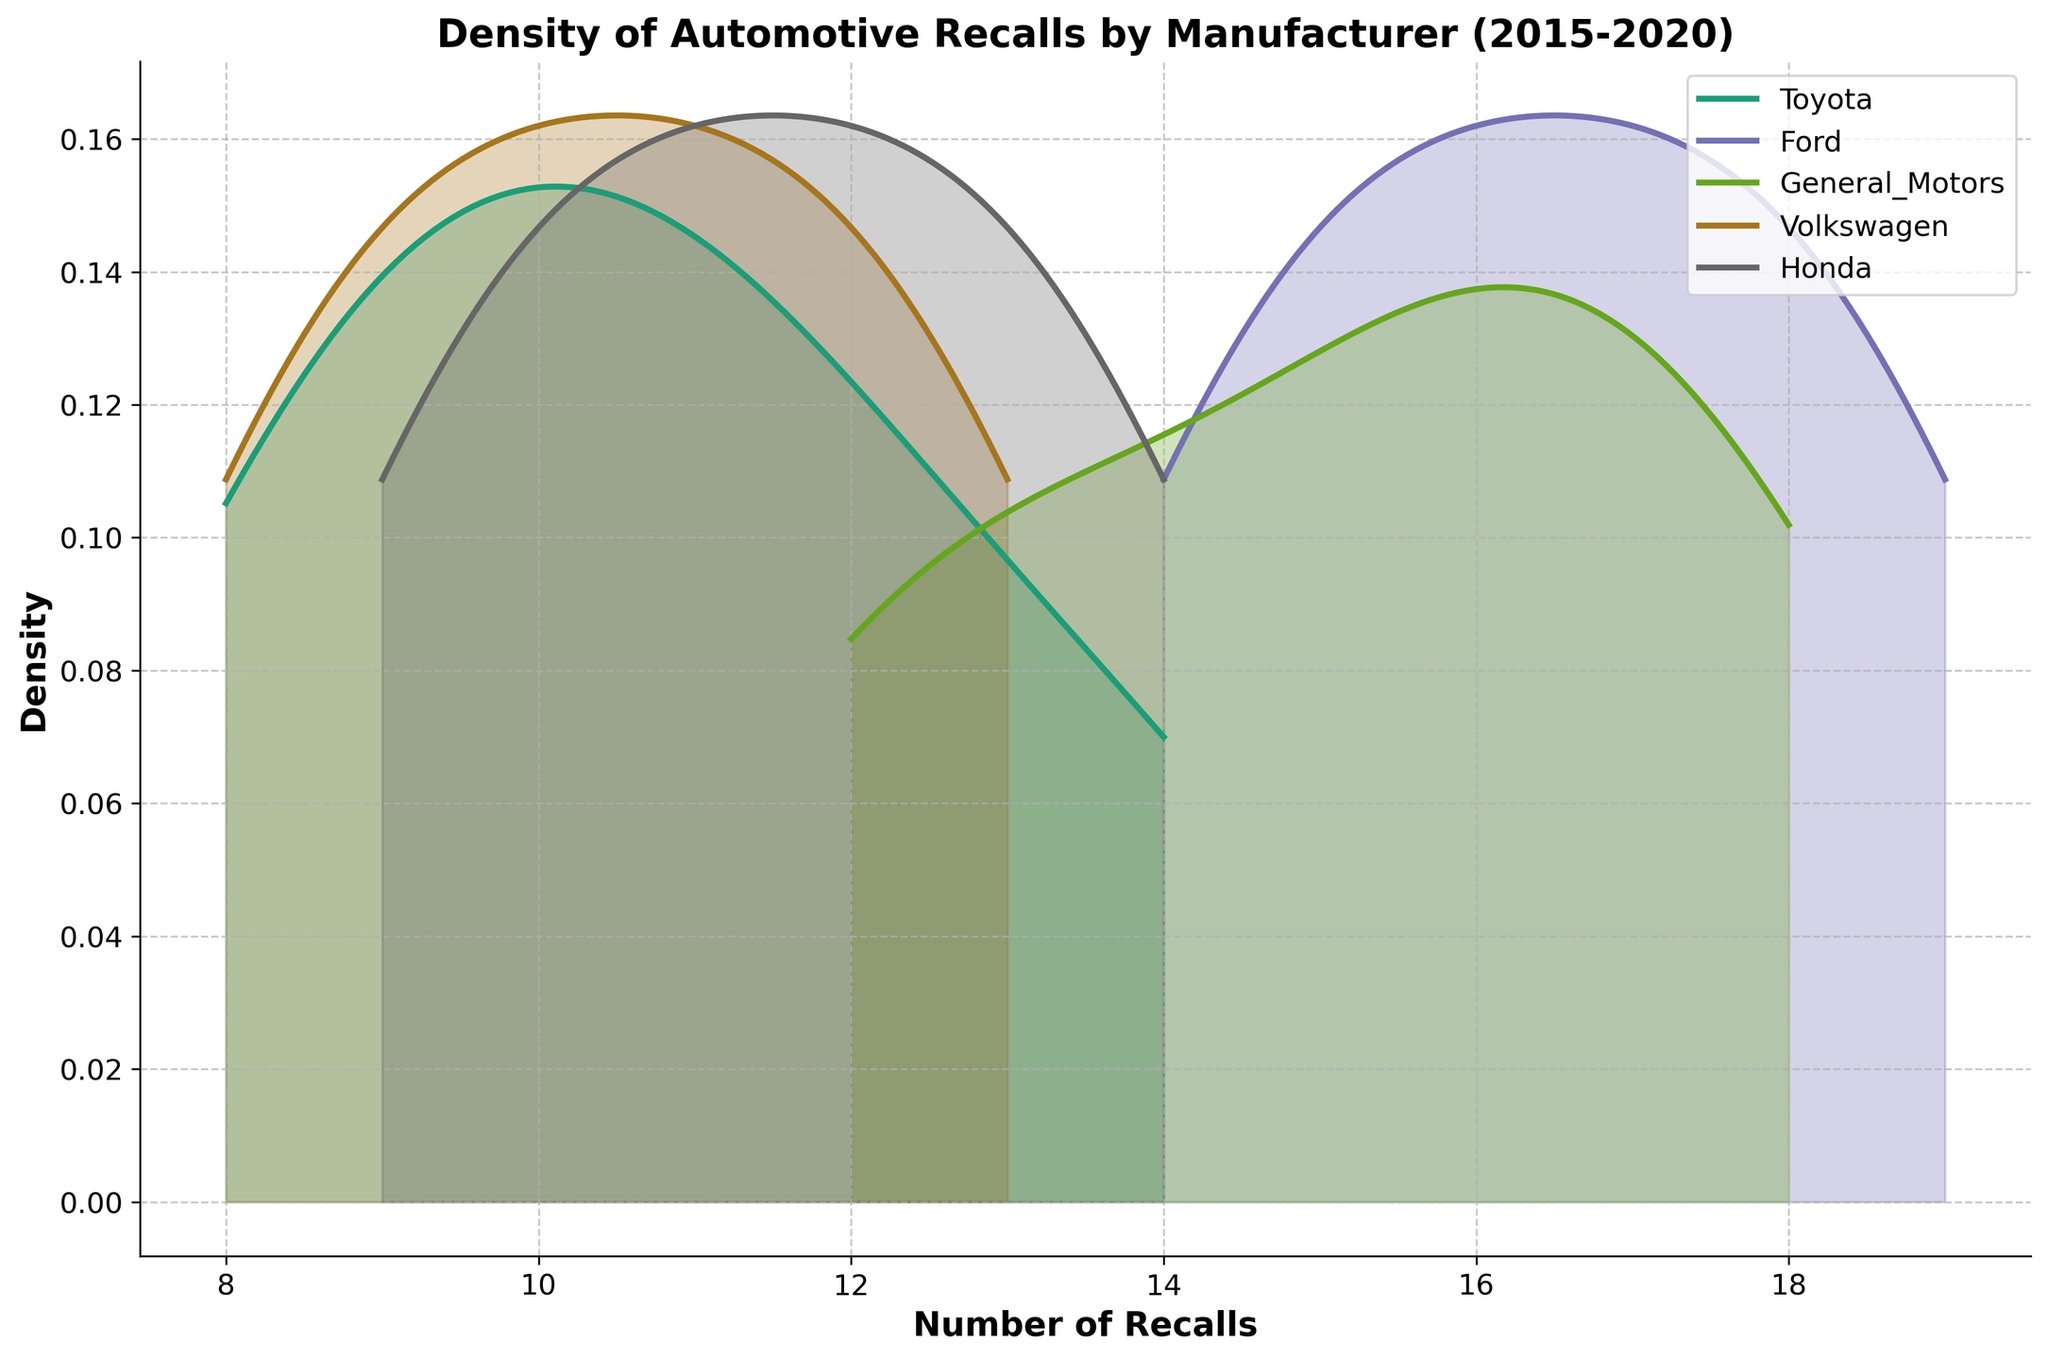What is the title of the figure? The title is located at the top center of the figure, written in bold font. It describes the overall topic of the plot.
Answer: Density of Automotive Recalls by Manufacturer (2015-2020) What does the x-axis represent? The label for the x-axis is found at the bottom of the plot, written in bold font. It indicates the variable being plotted along the x-axis.
Answer: Number of Recalls Which manufacturer appears to have the highest peak density of recalls? To determine this, look for the density curve that reaches the highest point on the y-axis.
Answer: Ford How many manufacturers' data are represented in the plot? The legend on the plot provides names of all the manufacturers. Count the number of unique names listed.
Answer: 5 Which two manufacturers have density curves that overlap the most? Observe the plot to see which density curves have the most significant overlap or share a similar range of values.
Answer: General Motors and Ford What is the approximate range of recalls for Toyota based on the density plot? Examine where the density curve for Toyota starts and ends along the x-axis.
Answer: From about 8 to 14 recalls Which manufacturer has the widest spread of recall densities? Look for the manufacturer whose density curve spans the largest range on the x-axis.
Answer: Ford Are there any manufacturers whose recall densities do not overlap with each other? Check each pair of density curves to see if there is no shared x-axis range (no overlap in density areas).
Answer: No, all manufacturers' density curves overlap to some extent On average, does Volkswagen have more or fewer recalls than Honda? Evaluate the central tendency of the density curves for Volkswagen and Honda on the x-axis to compare their average recall numbers.
Answer: Fewer In what year span is the data collected? The title or the legend may include the time span of the data collection.
Answer: 2015-2020 